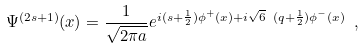<formula> <loc_0><loc_0><loc_500><loc_500>\Psi ^ { ( 2 s + 1 ) } ( x ) = \frac { 1 } { \sqrt { 2 \pi a } } e ^ { i ( s + \frac { 1 } { 2 } ) \phi ^ { + } ( x ) + i \sqrt { 6 } \ ( q + \frac { 1 } { 2 } ) \phi ^ { - } ( x ) } \ ,</formula> 